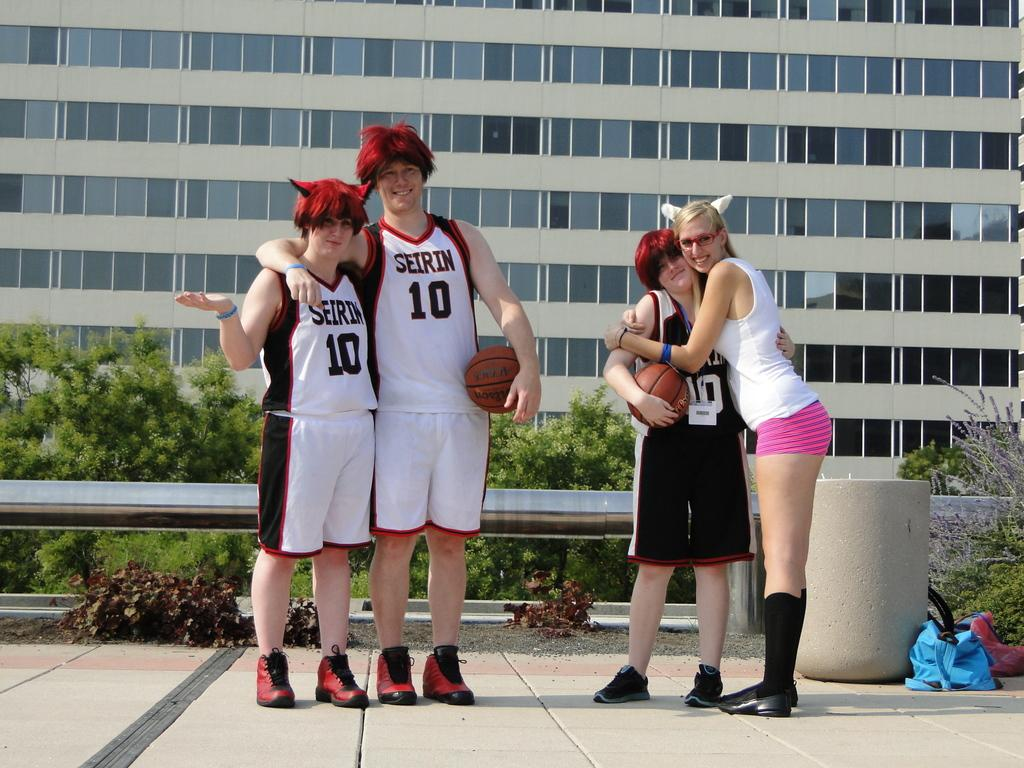<image>
Create a compact narrative representing the image presented. a couple basketball players that are wearing the number 10 